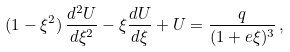<formula> <loc_0><loc_0><loc_500><loc_500>( 1 - \xi ^ { 2 } ) \, \frac { d ^ { 2 } U } { d \xi ^ { 2 } } - \xi \frac { d U } { d \xi } + U = \frac { q } { ( 1 + e \xi ) ^ { 3 } } \, ,</formula> 